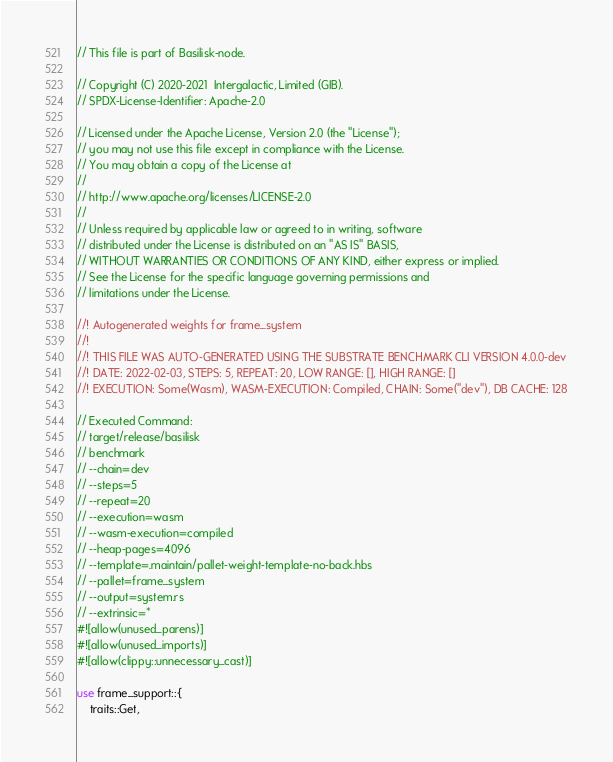<code> <loc_0><loc_0><loc_500><loc_500><_Rust_>// This file is part of Basilisk-node.

// Copyright (C) 2020-2021  Intergalactic, Limited (GIB).
// SPDX-License-Identifier: Apache-2.0

// Licensed under the Apache License, Version 2.0 (the "License");
// you may not use this file except in compliance with the License.
// You may obtain a copy of the License at
//
// http://www.apache.org/licenses/LICENSE-2.0
//
// Unless required by applicable law or agreed to in writing, software
// distributed under the License is distributed on an "AS IS" BASIS,
// WITHOUT WARRANTIES OR CONDITIONS OF ANY KIND, either express or implied.
// See the License for the specific language governing permissions and
// limitations under the License.

//! Autogenerated weights for frame_system
//!
//! THIS FILE WAS AUTO-GENERATED USING THE SUBSTRATE BENCHMARK CLI VERSION 4.0.0-dev
//! DATE: 2022-02-03, STEPS: 5, REPEAT: 20, LOW RANGE: [], HIGH RANGE: []
//! EXECUTION: Some(Wasm), WASM-EXECUTION: Compiled, CHAIN: Some("dev"), DB CACHE: 128

// Executed Command:
// target/release/basilisk
// benchmark
// --chain=dev
// --steps=5
// --repeat=20
// --execution=wasm
// --wasm-execution=compiled
// --heap-pages=4096
// --template=.maintain/pallet-weight-template-no-back.hbs
// --pallet=frame_system
// --output=system.rs
// --extrinsic=*
#![allow(unused_parens)]
#![allow(unused_imports)]
#![allow(clippy::unnecessary_cast)]

use frame_support::{
	traits::Get,</code> 